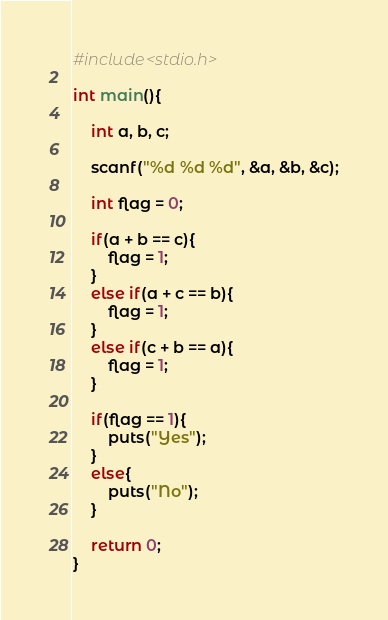Convert code to text. <code><loc_0><loc_0><loc_500><loc_500><_C_>#include<stdio.h>

int main(){
	
	int a, b, c;
	
	scanf("%d %d %d", &a, &b, &c);
	
	int flag = 0;
	
	if(a + b == c){
		flag = 1;
	}
	else if(a + c == b){
		flag = 1;
	}
	else if(c + b == a){
		flag = 1;
	}
	
	if(flag == 1){
		puts("Yes");
	}
	else{
		puts("No");
	}
	
	return 0;
}</code> 